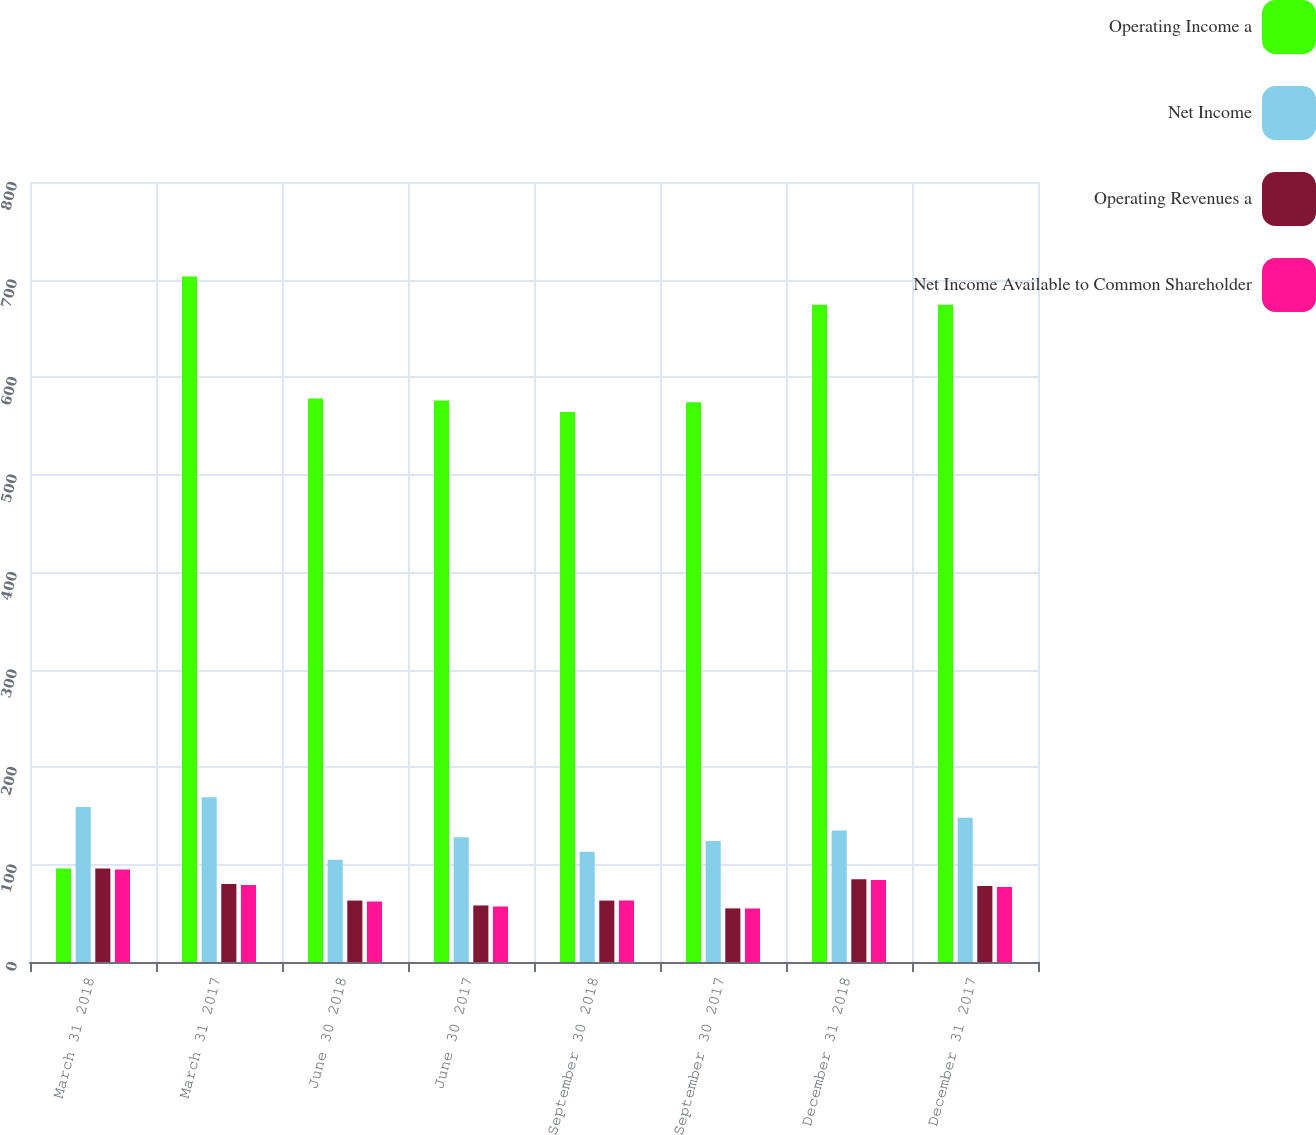Convert chart to OTSL. <chart><loc_0><loc_0><loc_500><loc_500><stacked_bar_chart><ecel><fcel>March 31 2018<fcel>March 31 2017<fcel>June 30 2018<fcel>June 30 2017<fcel>September 30 2018<fcel>September 30 2017<fcel>December 31 2018<fcel>December 31 2017<nl><fcel>Operating Income a<fcel>96<fcel>703<fcel>578<fcel>576<fcel>564<fcel>574<fcel>674<fcel>674<nl><fcel>Net Income<fcel>159<fcel>169<fcel>105<fcel>128<fcel>113<fcel>124<fcel>135<fcel>148<nl><fcel>Operating Revenues a<fcel>96<fcel>80<fcel>63<fcel>58<fcel>63<fcel>55<fcel>85<fcel>78<nl><fcel>Net Income Available to Common Shareholder<fcel>95<fcel>79<fcel>62<fcel>57<fcel>63<fcel>55<fcel>84<fcel>77<nl></chart> 